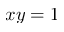Convert formula to latex. <formula><loc_0><loc_0><loc_500><loc_500>x y = 1</formula> 